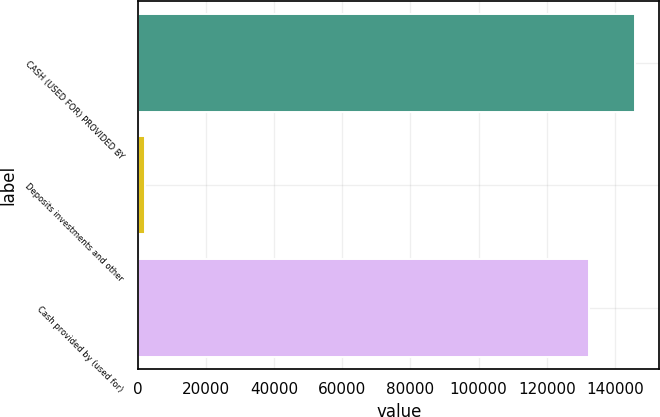Convert chart. <chart><loc_0><loc_0><loc_500><loc_500><bar_chart><fcel>CASH (USED FOR) PROVIDED BY<fcel>Deposits investments and other<fcel>Cash provided by (used for)<nl><fcel>145794<fcel>2000<fcel>132540<nl></chart> 